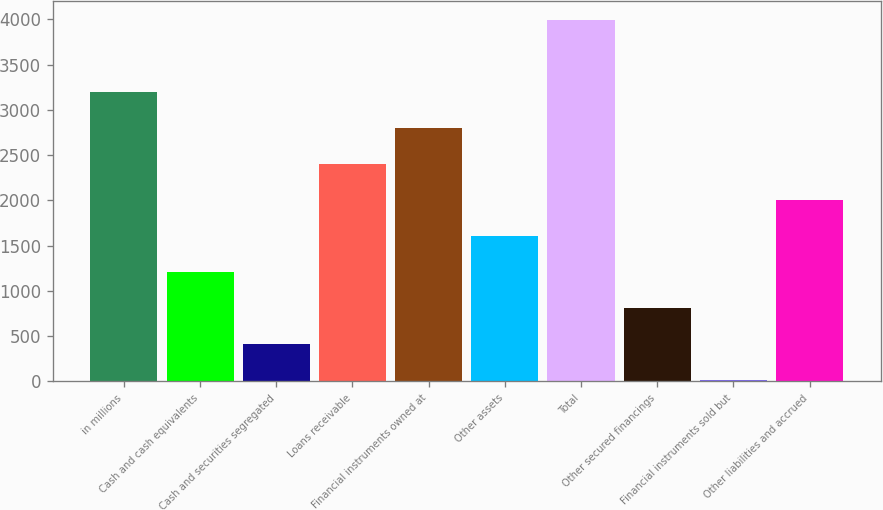<chart> <loc_0><loc_0><loc_500><loc_500><bar_chart><fcel>in millions<fcel>Cash and cash equivalents<fcel>Cash and securities segregated<fcel>Loans receivable<fcel>Financial instruments owned at<fcel>Other assets<fcel>Total<fcel>Other secured financings<fcel>Financial instruments sold but<fcel>Other liabilities and accrued<nl><fcel>3202.4<fcel>1210.9<fcel>414.3<fcel>2405.8<fcel>2804.1<fcel>1609.2<fcel>3999<fcel>812.6<fcel>16<fcel>2007.5<nl></chart> 